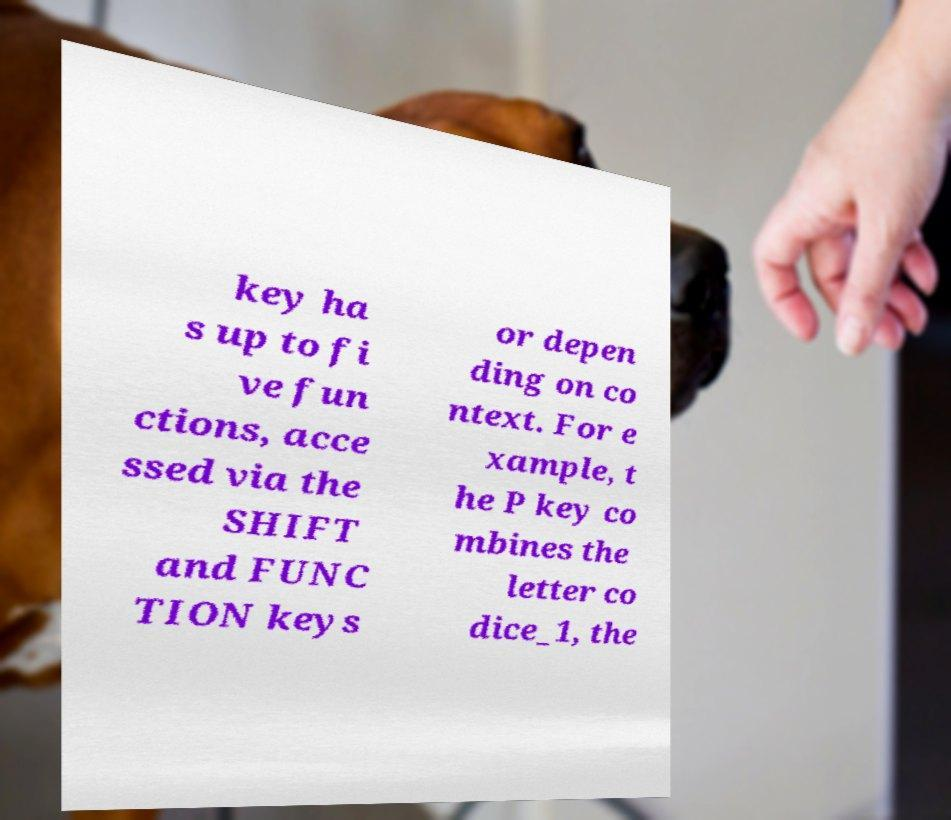Can you read and provide the text displayed in the image?This photo seems to have some interesting text. Can you extract and type it out for me? key ha s up to fi ve fun ctions, acce ssed via the SHIFT and FUNC TION keys or depen ding on co ntext. For e xample, t he P key co mbines the letter co dice_1, the 